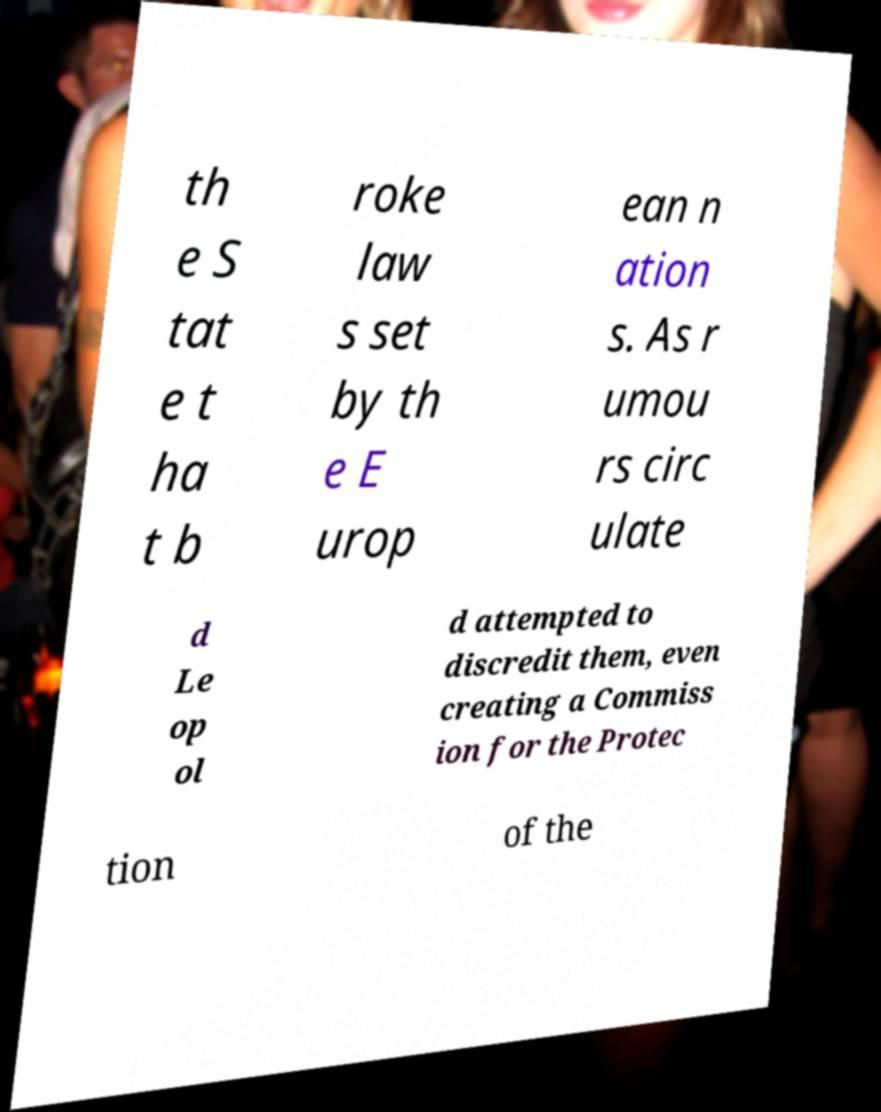Please read and relay the text visible in this image. What does it say? th e S tat e t ha t b roke law s set by th e E urop ean n ation s. As r umou rs circ ulate d Le op ol d attempted to discredit them, even creating a Commiss ion for the Protec tion of the 